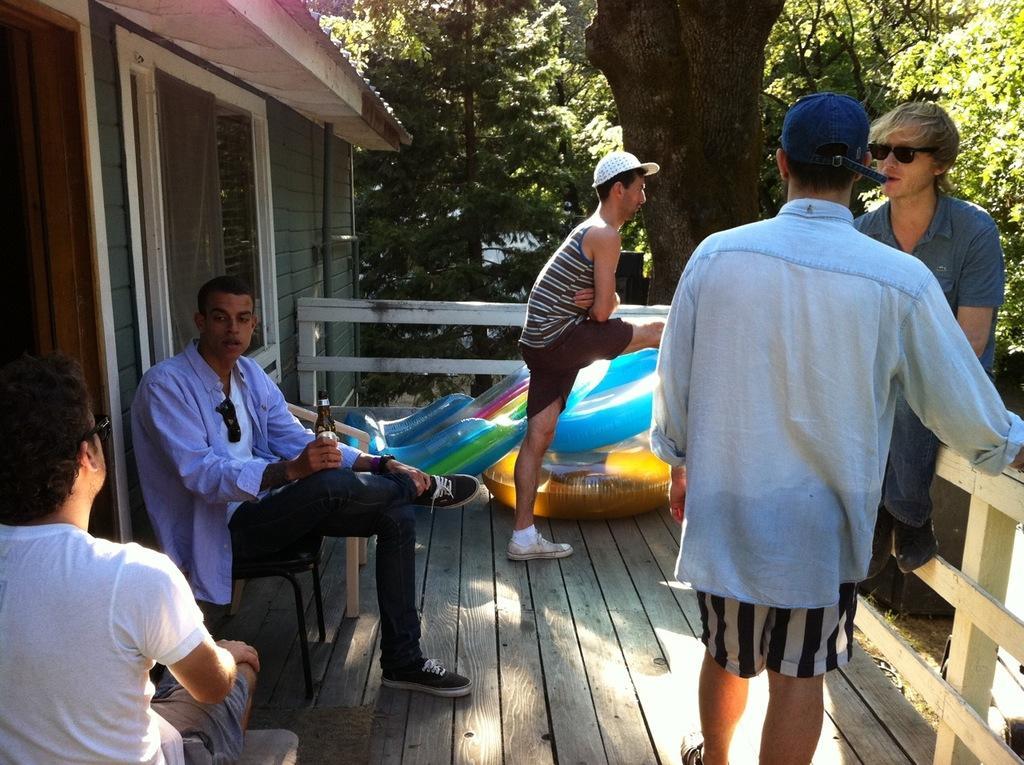Could you give a brief overview of what you see in this image? In the foreground of this image, there are men standing and sitting on a wooden surface and also a man is holding a bottle. On the left, there is a wall, window and the roof. Behind them, there is a wooden railing, few inflatable objects and the trees. 